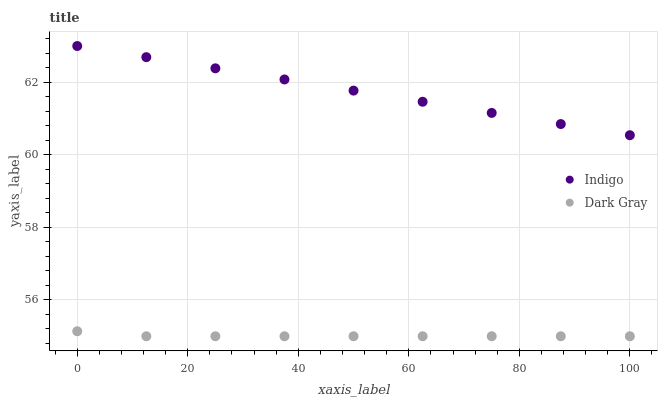Does Dark Gray have the minimum area under the curve?
Answer yes or no. Yes. Does Indigo have the maximum area under the curve?
Answer yes or no. Yes. Does Indigo have the minimum area under the curve?
Answer yes or no. No. Is Indigo the smoothest?
Answer yes or no. Yes. Is Dark Gray the roughest?
Answer yes or no. Yes. Is Indigo the roughest?
Answer yes or no. No. Does Dark Gray have the lowest value?
Answer yes or no. Yes. Does Indigo have the lowest value?
Answer yes or no. No. Does Indigo have the highest value?
Answer yes or no. Yes. Is Dark Gray less than Indigo?
Answer yes or no. Yes. Is Indigo greater than Dark Gray?
Answer yes or no. Yes. Does Dark Gray intersect Indigo?
Answer yes or no. No. 